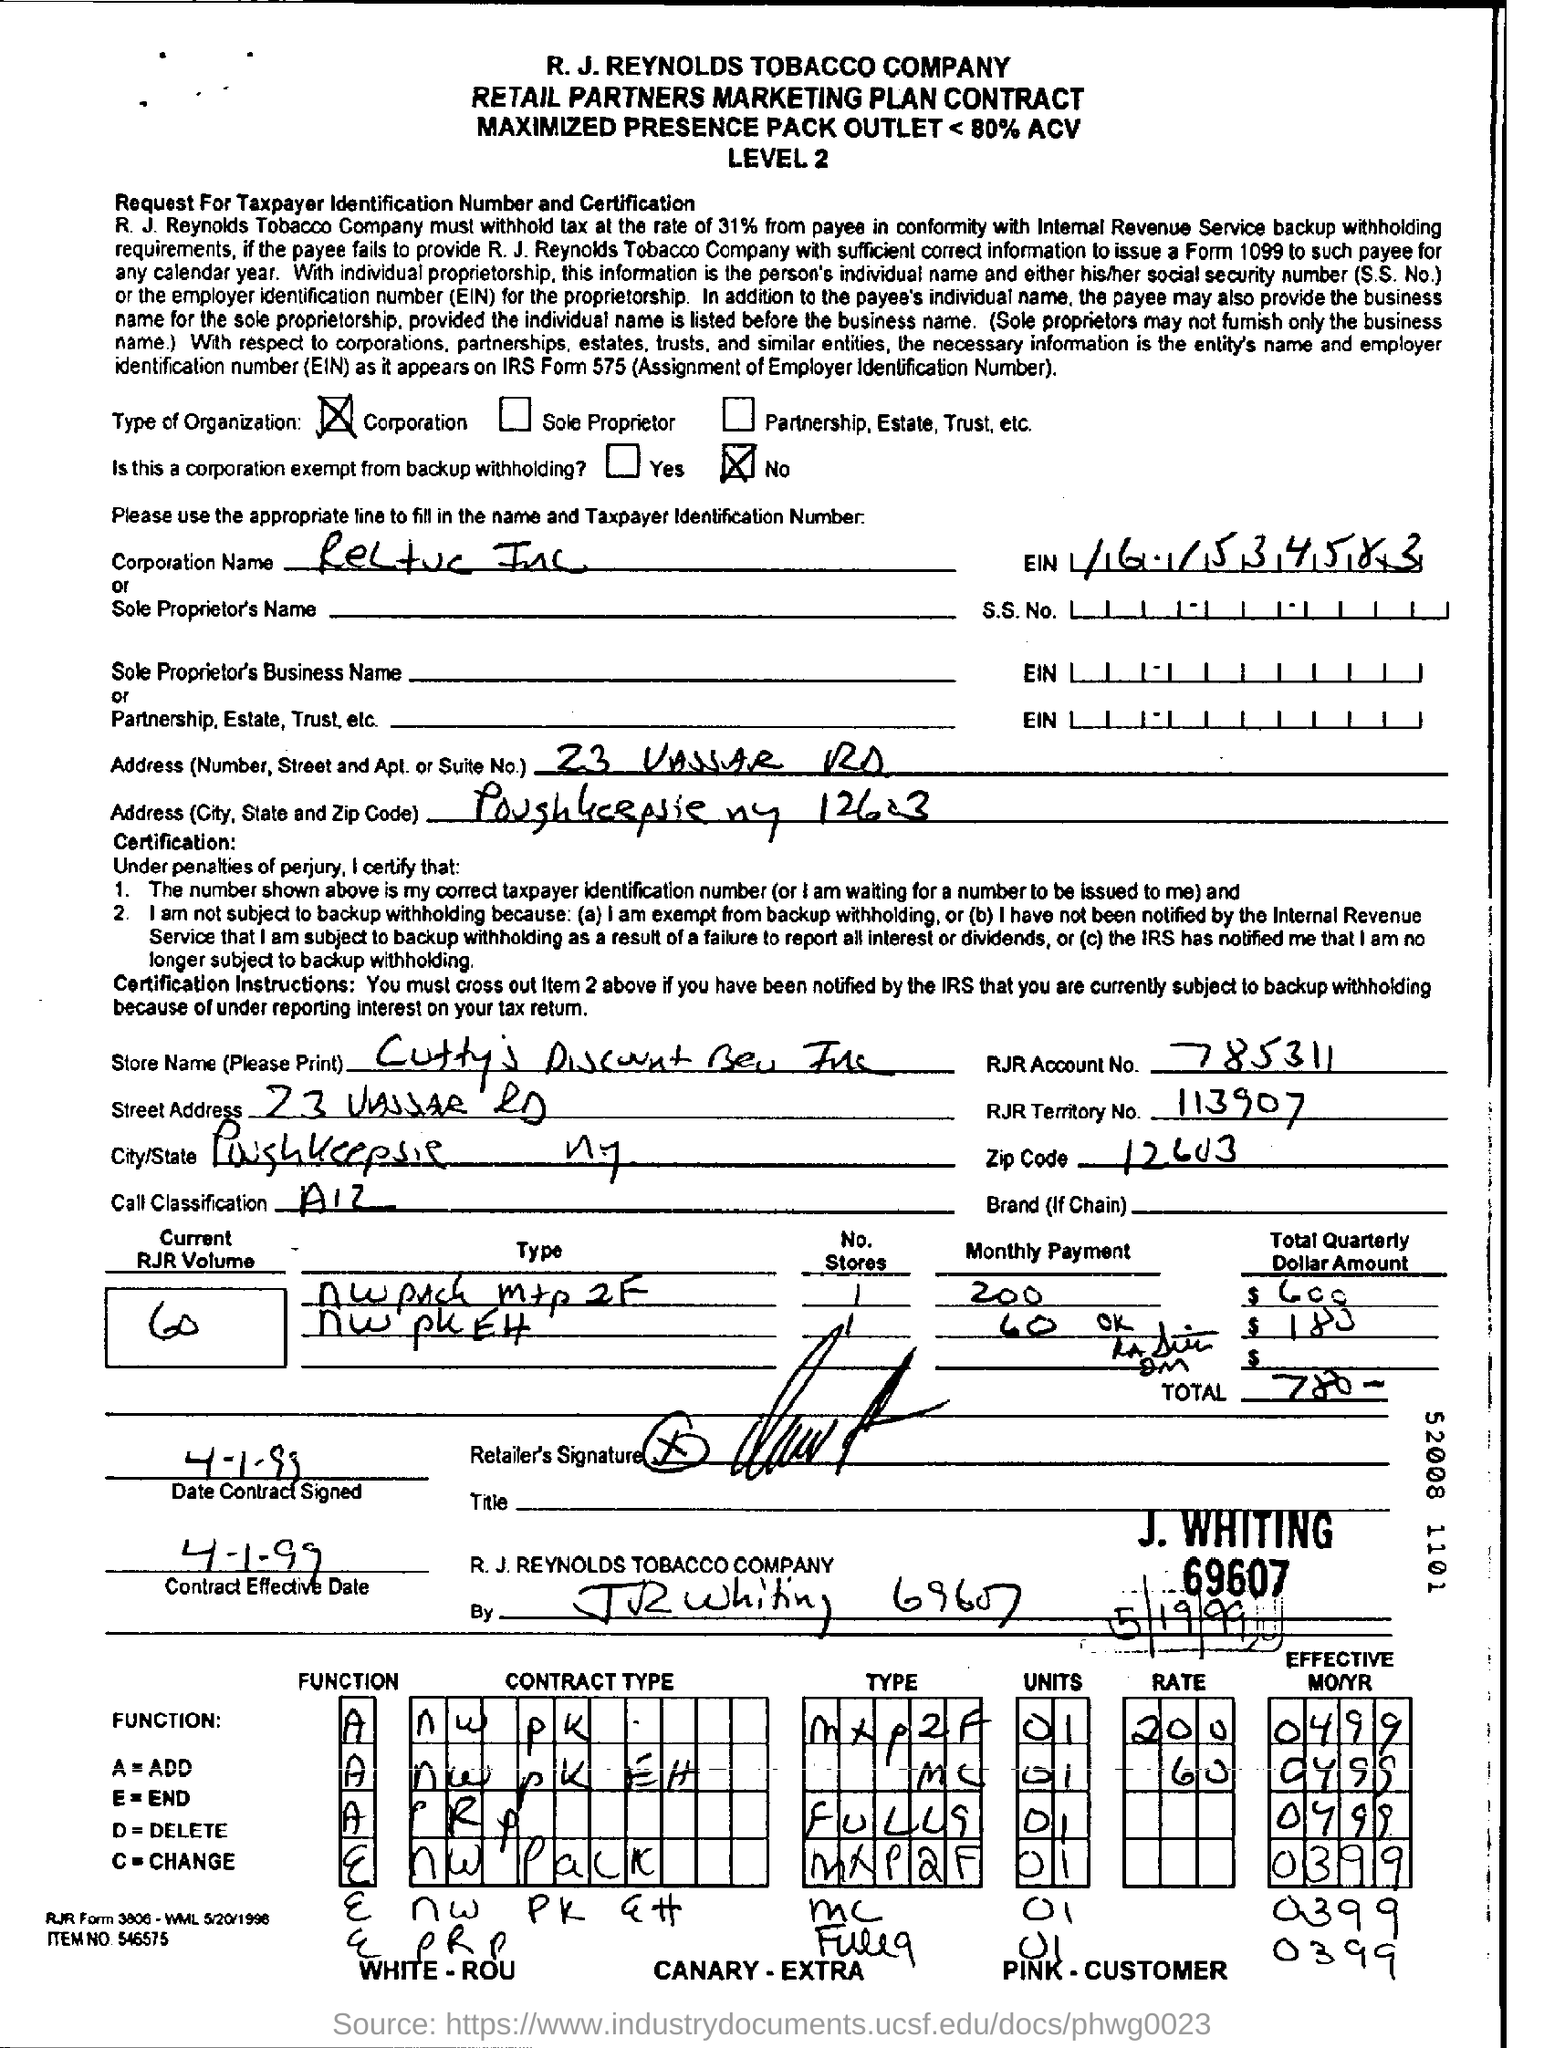Point out several critical features in this image. The RJR Account number is 785311... The RJR account number provided in the form is 785311... 